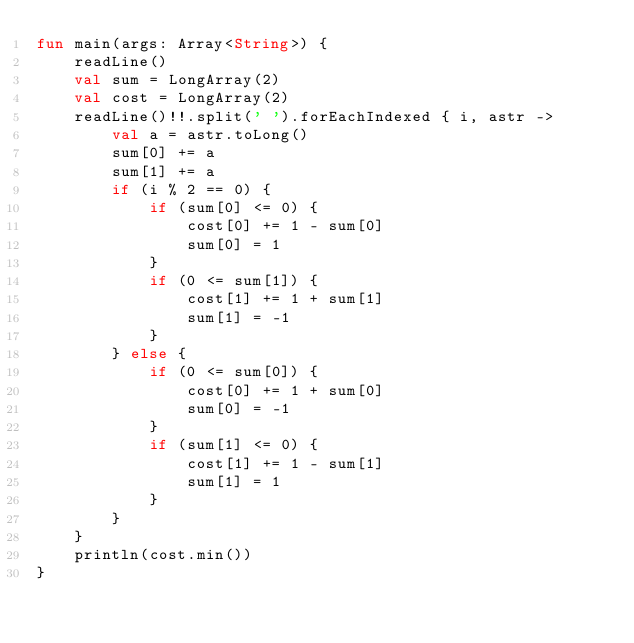Convert code to text. <code><loc_0><loc_0><loc_500><loc_500><_Kotlin_>fun main(args: Array<String>) {
    readLine()
    val sum = LongArray(2)
    val cost = LongArray(2)
    readLine()!!.split(' ').forEachIndexed { i, astr ->
        val a = astr.toLong()
        sum[0] += a
        sum[1] += a
        if (i % 2 == 0) {
            if (sum[0] <= 0) {
                cost[0] += 1 - sum[0]
                sum[0] = 1
            }
            if (0 <= sum[1]) {
                cost[1] += 1 + sum[1]
                sum[1] = -1
            }
        } else {
            if (0 <= sum[0]) {
                cost[0] += 1 + sum[0]
                sum[0] = -1
            }
            if (sum[1] <= 0) {
                cost[1] += 1 - sum[1]
                sum[1] = 1
            }
        }
    }
    println(cost.min())
}
</code> 